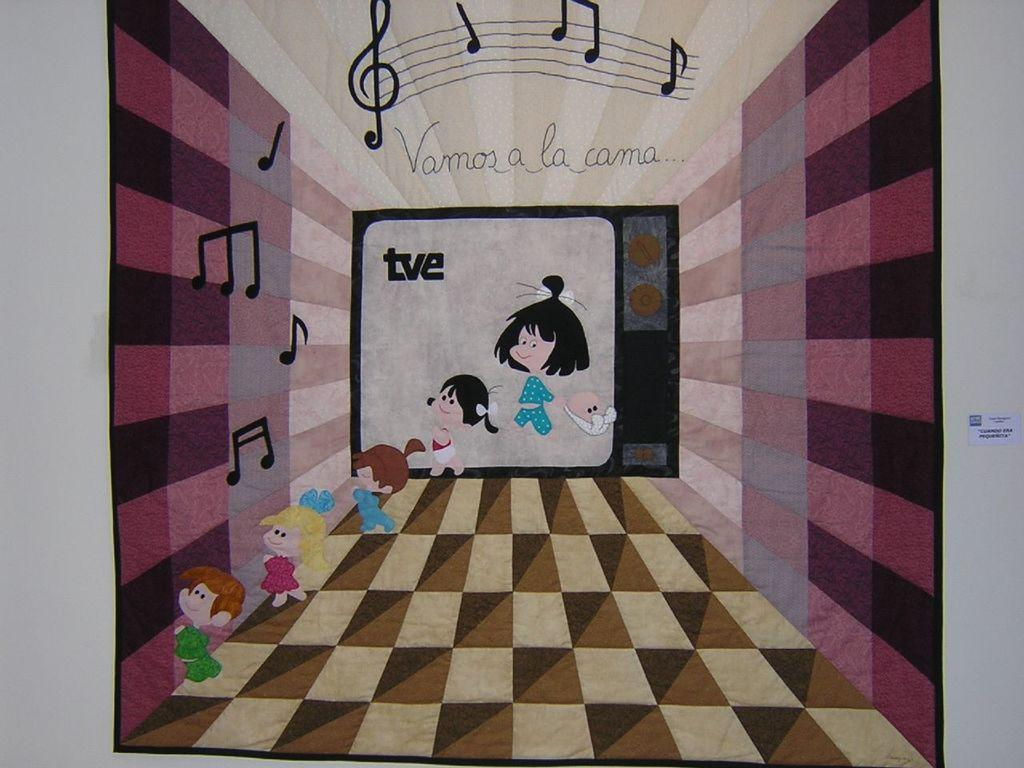<image>
Present a compact description of the photo's key features. animated poster with the words vamos a la cama 